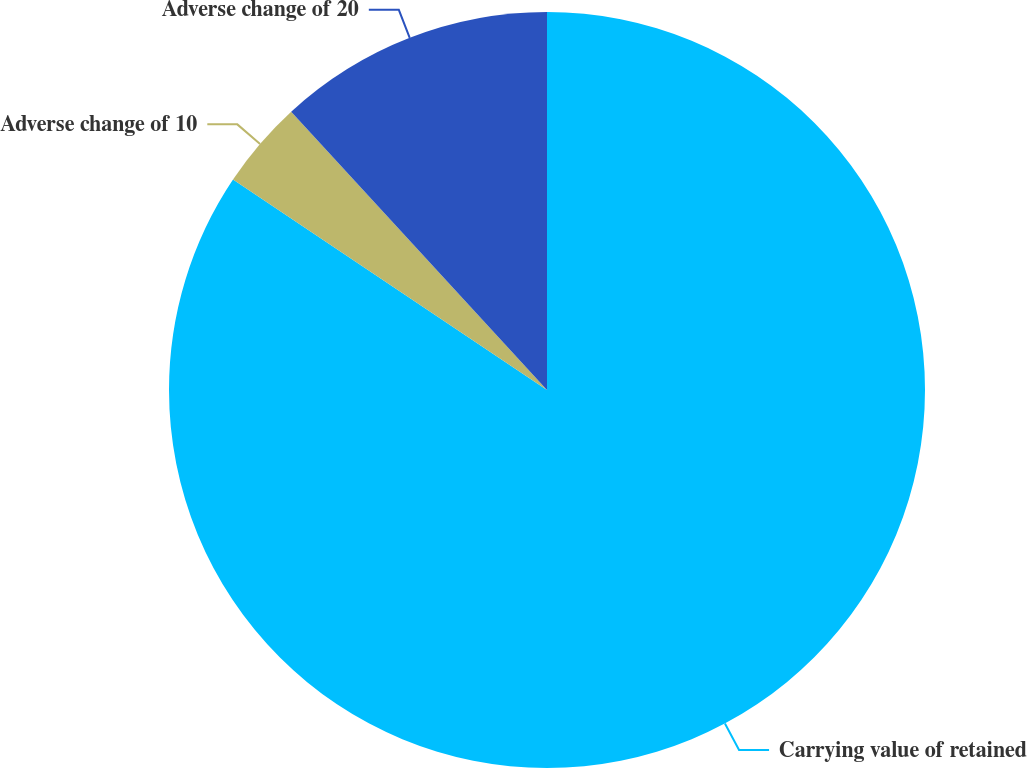Convert chart. <chart><loc_0><loc_0><loc_500><loc_500><pie_chart><fcel>Carrying value of retained<fcel>Adverse change of 10<fcel>Adverse change of 20<nl><fcel>84.39%<fcel>3.77%<fcel>11.83%<nl></chart> 